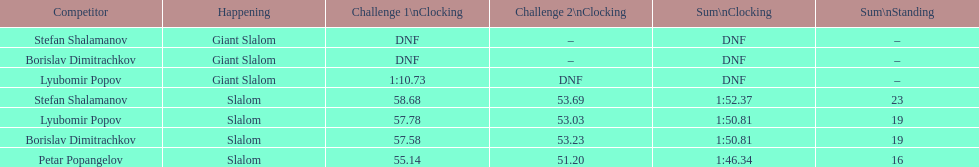What is the total number of athletes? 4. 